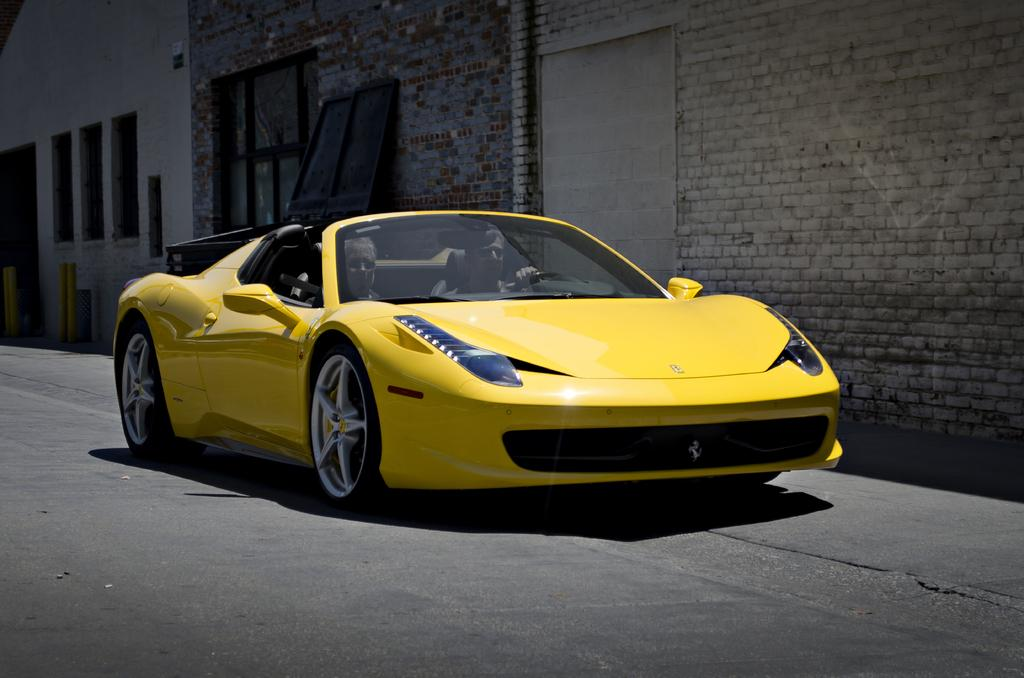What is the main subject of the image? The main subject of the image is a car on the road. How many people are inside the car? There are two people inside the car. What can be seen in the background of the image? In the background of the image, there is an object, a wall, windows, and metal poles. What type of channel can be seen running through the car in the image? There is no channel visible in the image, and the car is not depicted as having a channel running through it. 